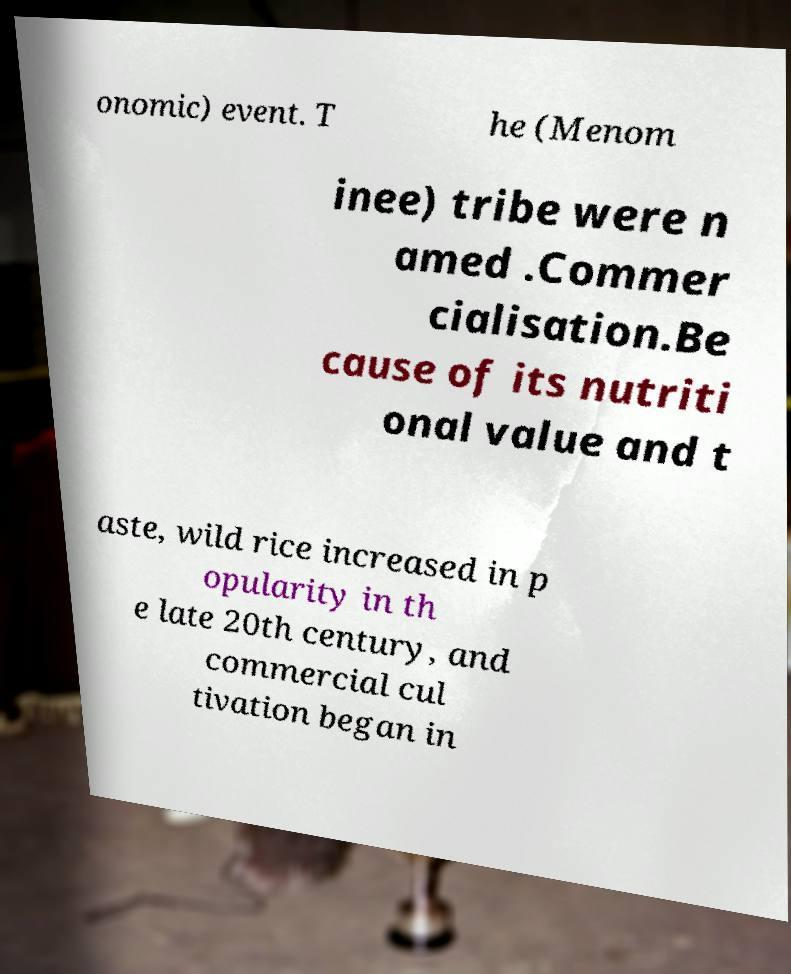Please read and relay the text visible in this image. What does it say? onomic) event. T he (Menom inee) tribe were n amed .Commer cialisation.Be cause of its nutriti onal value and t aste, wild rice increased in p opularity in th e late 20th century, and commercial cul tivation began in 